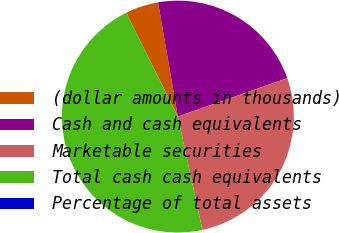<chart> <loc_0><loc_0><loc_500><loc_500><pie_chart><fcel>(dollar amounts in thousands)<fcel>Cash and cash equivalents<fcel>Marketable securities<fcel>Total cash cash equivalents<fcel>Percentage of total assets<nl><fcel>4.61%<fcel>22.36%<fcel>26.97%<fcel>46.06%<fcel>0.0%<nl></chart> 